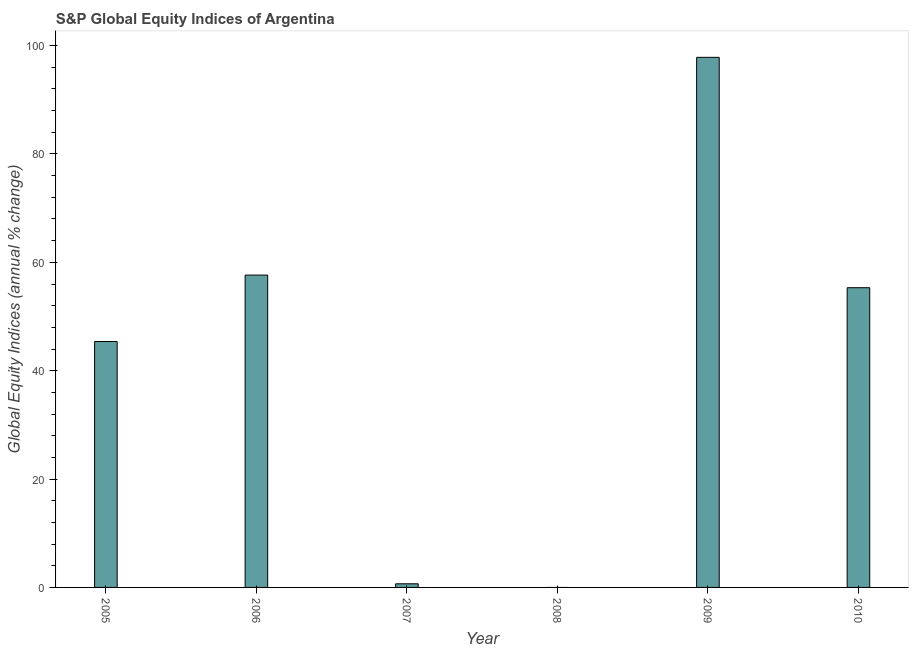Does the graph contain any zero values?
Give a very brief answer. Yes. Does the graph contain grids?
Provide a succinct answer. No. What is the title of the graph?
Offer a very short reply. S&P Global Equity Indices of Argentina. What is the label or title of the Y-axis?
Offer a terse response. Global Equity Indices (annual % change). What is the s&p global equity indices in 2007?
Offer a terse response. 0.67. Across all years, what is the maximum s&p global equity indices?
Provide a succinct answer. 97.84. What is the sum of the s&p global equity indices?
Give a very brief answer. 256.86. What is the difference between the s&p global equity indices in 2005 and 2006?
Provide a short and direct response. -12.26. What is the average s&p global equity indices per year?
Your answer should be very brief. 42.81. What is the median s&p global equity indices?
Your answer should be compact. 50.35. In how many years, is the s&p global equity indices greater than 60 %?
Keep it short and to the point. 1. What is the ratio of the s&p global equity indices in 2005 to that in 2010?
Your response must be concise. 0.82. Is the s&p global equity indices in 2005 less than that in 2010?
Give a very brief answer. Yes. What is the difference between the highest and the second highest s&p global equity indices?
Ensure brevity in your answer.  40.19. What is the difference between the highest and the lowest s&p global equity indices?
Your answer should be compact. 97.84. In how many years, is the s&p global equity indices greater than the average s&p global equity indices taken over all years?
Provide a short and direct response. 4. How many bars are there?
Provide a succinct answer. 5. Are all the bars in the graph horizontal?
Your answer should be very brief. No. How many years are there in the graph?
Offer a very short reply. 6. What is the difference between two consecutive major ticks on the Y-axis?
Give a very brief answer. 20. What is the Global Equity Indices (annual % change) of 2005?
Your answer should be very brief. 45.39. What is the Global Equity Indices (annual % change) in 2006?
Your answer should be very brief. 57.65. What is the Global Equity Indices (annual % change) of 2007?
Give a very brief answer. 0.67. What is the Global Equity Indices (annual % change) of 2008?
Give a very brief answer. 0. What is the Global Equity Indices (annual % change) in 2009?
Offer a terse response. 97.84. What is the Global Equity Indices (annual % change) of 2010?
Ensure brevity in your answer.  55.32. What is the difference between the Global Equity Indices (annual % change) in 2005 and 2006?
Make the answer very short. -12.26. What is the difference between the Global Equity Indices (annual % change) in 2005 and 2007?
Make the answer very short. 44.72. What is the difference between the Global Equity Indices (annual % change) in 2005 and 2009?
Offer a terse response. -52.45. What is the difference between the Global Equity Indices (annual % change) in 2005 and 2010?
Offer a very short reply. -9.93. What is the difference between the Global Equity Indices (annual % change) in 2006 and 2007?
Offer a terse response. 56.98. What is the difference between the Global Equity Indices (annual % change) in 2006 and 2009?
Ensure brevity in your answer.  -40.19. What is the difference between the Global Equity Indices (annual % change) in 2006 and 2010?
Provide a succinct answer. 2.33. What is the difference between the Global Equity Indices (annual % change) in 2007 and 2009?
Your answer should be very brief. -97.17. What is the difference between the Global Equity Indices (annual % change) in 2007 and 2010?
Give a very brief answer. -54.65. What is the difference between the Global Equity Indices (annual % change) in 2009 and 2010?
Your answer should be compact. 42.52. What is the ratio of the Global Equity Indices (annual % change) in 2005 to that in 2006?
Give a very brief answer. 0.79. What is the ratio of the Global Equity Indices (annual % change) in 2005 to that in 2007?
Keep it short and to the point. 67.84. What is the ratio of the Global Equity Indices (annual % change) in 2005 to that in 2009?
Offer a terse response. 0.46. What is the ratio of the Global Equity Indices (annual % change) in 2005 to that in 2010?
Offer a very short reply. 0.82. What is the ratio of the Global Equity Indices (annual % change) in 2006 to that in 2007?
Your answer should be compact. 86.17. What is the ratio of the Global Equity Indices (annual % change) in 2006 to that in 2009?
Keep it short and to the point. 0.59. What is the ratio of the Global Equity Indices (annual % change) in 2006 to that in 2010?
Your response must be concise. 1.04. What is the ratio of the Global Equity Indices (annual % change) in 2007 to that in 2009?
Offer a terse response. 0.01. What is the ratio of the Global Equity Indices (annual % change) in 2007 to that in 2010?
Give a very brief answer. 0.01. What is the ratio of the Global Equity Indices (annual % change) in 2009 to that in 2010?
Your response must be concise. 1.77. 